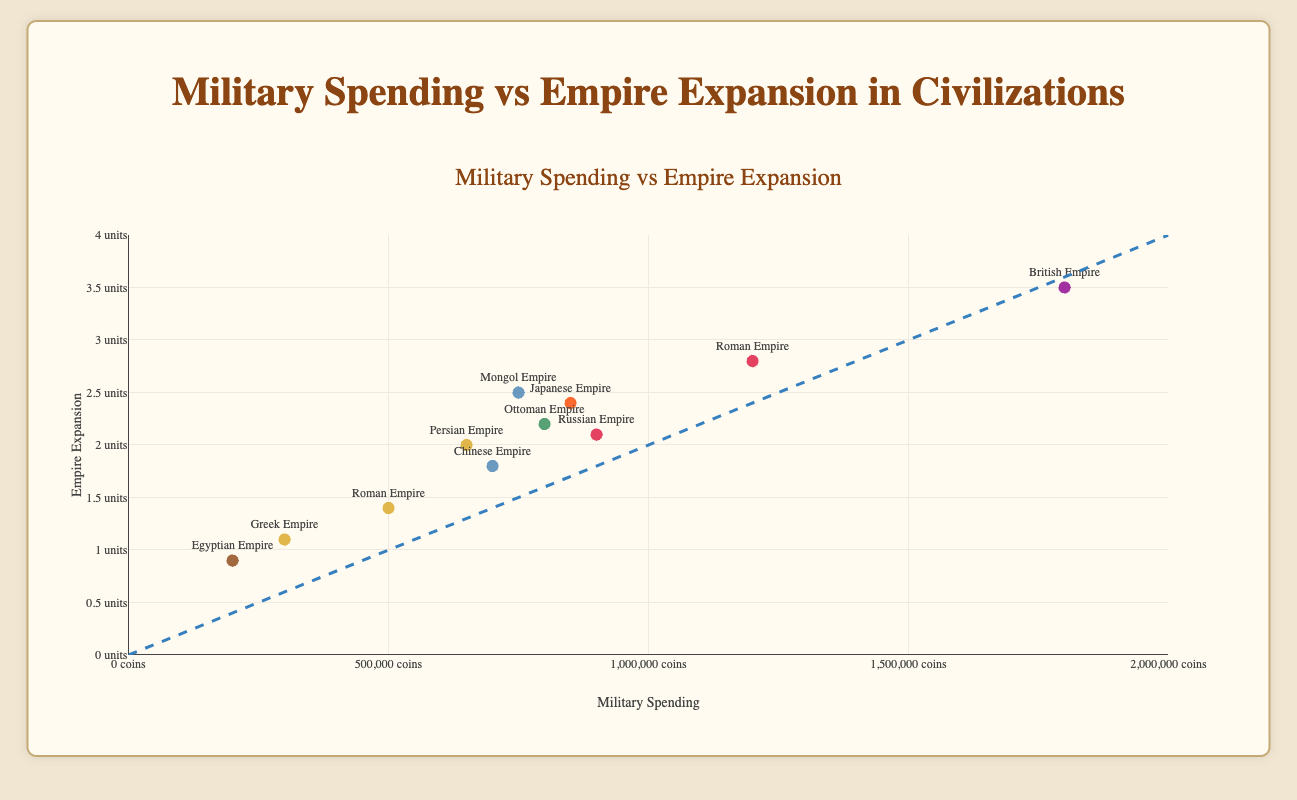Which civilization had the highest empire expansion? By examining the y-axis, we can see that the British Empire has the highest value for empire expansion at 3.5 units.
Answer: British Empire What is the relationship between military spending and empire expansion, according to the trend line? The trend line generally shows a positive correlation between military spending and empire expansion, meaning higher military spending tends to align with greater empire expansion.
Answer: Positive correlation Which civilization spent the least on the military? From the plot that maps military spending on the x-axis, the Egyptian Empire has the lowest spending value at 200,000 coins.
Answer: Egyptian Empire What is the combined military spending of the Greek Empire and the Egyptian Empire? The Greek Empire's spending is 300,000 coins, and the Egyptian Empire's spending is 200,000 coins. Adding these together gives 300,000 + 200,000 = 500,000 coins.
Answer: 500,000 coins Which civilization spent more on military: the Ottoman Empire or the Russian Empire? By looking at the data points on the x-axis for the Ottoman and Russian Empires, the Russian Empire spent more, with 900,000 coins compared to the Ottoman Empire's 800,000 coins.
Answer: Russian Empire How much higher is the empire expansion of the Roman Empire during the Imperial era compared to the Classical era? The Roman Empire's empire expansion in the Imperial era is 2.8 units, and in the Classical era, it is 1.4 units. The difference is 2.8 - 1.4 = 1.4 units.
Answer: 1.4 units Which civilizations fall on or very near the trend line? The trend line represents a balanced increase in military spending and empire expansion. Civilizations like the Persian Empire, the Mongol Empire, and the Ottoman Empire appear to be very close to this trend line.
Answer: Persian Empire, Mongol Empire, Ottoman Empire What are the ranges of military spending and empire expansion depicted in the plot? The x-axis range for military spending is from 0 to 2,000,000 coins, and the y-axis range for empire expansion is from 0 to 4 units.
Answer: 0 to 2,000,000 coins (military spending); 0 to 4 units (empire expansion) How does the Japanese Empire's military spending compare to its empire expansion? The Japanese Empire has military spending of 850,000 coins and empire expansion of 2.4 units. This shows a substantial investment in the military relative to its expansion.
Answer: Substantial relative to expansion What is the average empire expansion for civilizations depicted in the plot? Summing all the empire expansion values (1.4 + 2.8 + 1.1 + 0.9 + 2.0 + 3.5 + 2.5 + 2.2 + 1.8 + 2.4 + 2.1) and dividing by the number of civilizations (11) gives the average empire expansion: (24.7)/11 ≈ 2.245 units.
Answer: 2.245 units 